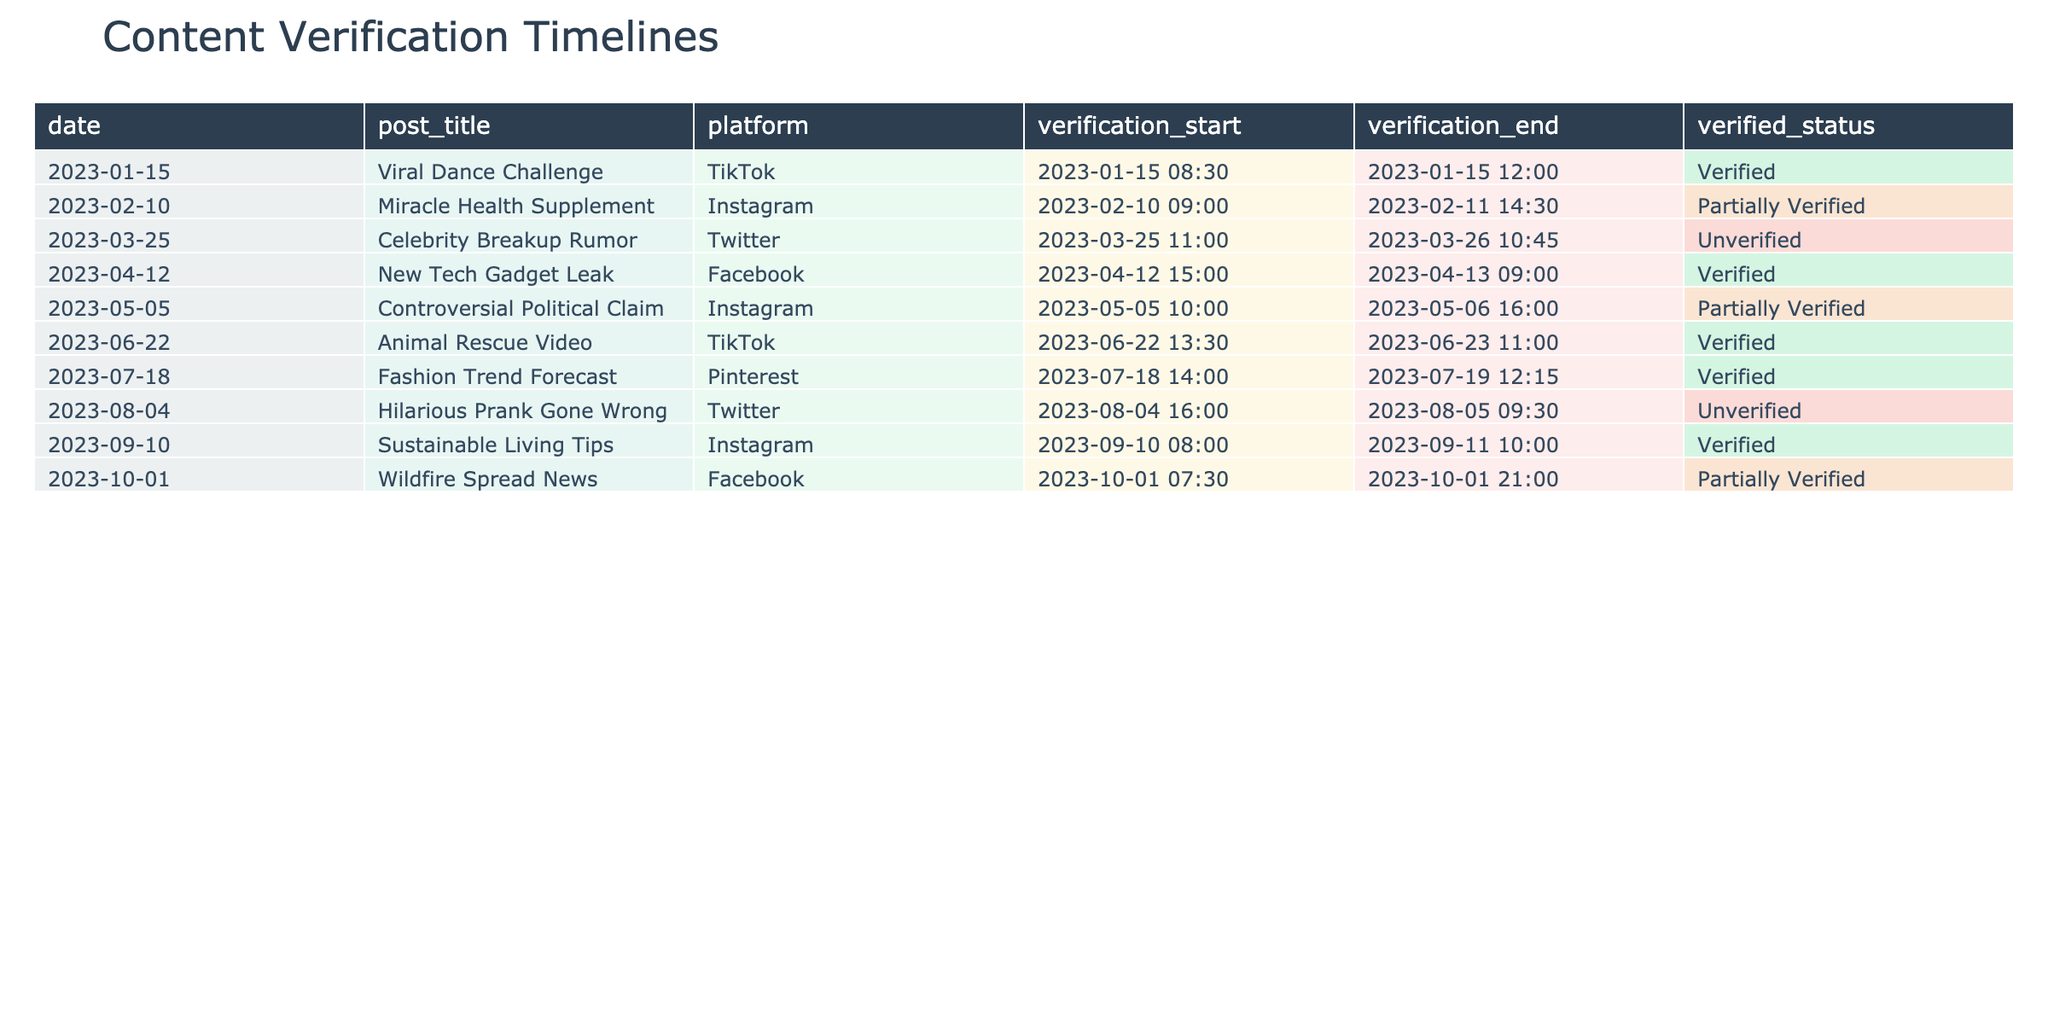What is the title of the post that was verified on January 15, 2023? Looking at the 'verification_start' date column, we find the entry for January 15, 2023, which corresponds to the post titled "Viral Dance Challenge."
Answer: Viral Dance Challenge How many posts were partially verified in total? By checking the 'verified_status' column, we count the instances of "Partially Verified." There are two posts that fall into this category: "Miracle Health Supplement" and "Wildfire Spread News."
Answer: 2 Which platform had the most verified posts? Aggregating the posts by platform and checking the 'verified_status', we find: TikTok has 2 verified posts, Instagram has 2, Facebook has 2, Pinterest has 1, and Twitter has 0. All platforms have the same number except Pinterest, making it a tie between TikTok, Instagram, and Facebook for the most verified posts.
Answer: TikTok, Instagram, and Facebook Is there any post verified that was created on a weekend? Analyzing the 'date' column, we identify the posts from a Saturday or Sunday. The only weekend entry is the one for January 15, 2023, when "Viral Dance Challenge" was verified. Thus, indeed there is a verified post created on a weekend.
Answer: Yes Which post took the longest time to verify? To determine the post with the longest verification period, we calculate the duration for each post by subtracting 'verification_start' from 'verification_end' as follows: "Miracle Health Supplement" is 29.5 hours, "Controversial Political Claim" is 23.75 hours, "New Tech Gadget Leak" is 18 hours, etc. The longest duration is for "Miracle Health Supplement" at 29.5 hours.
Answer: Miracle Health Supplement 